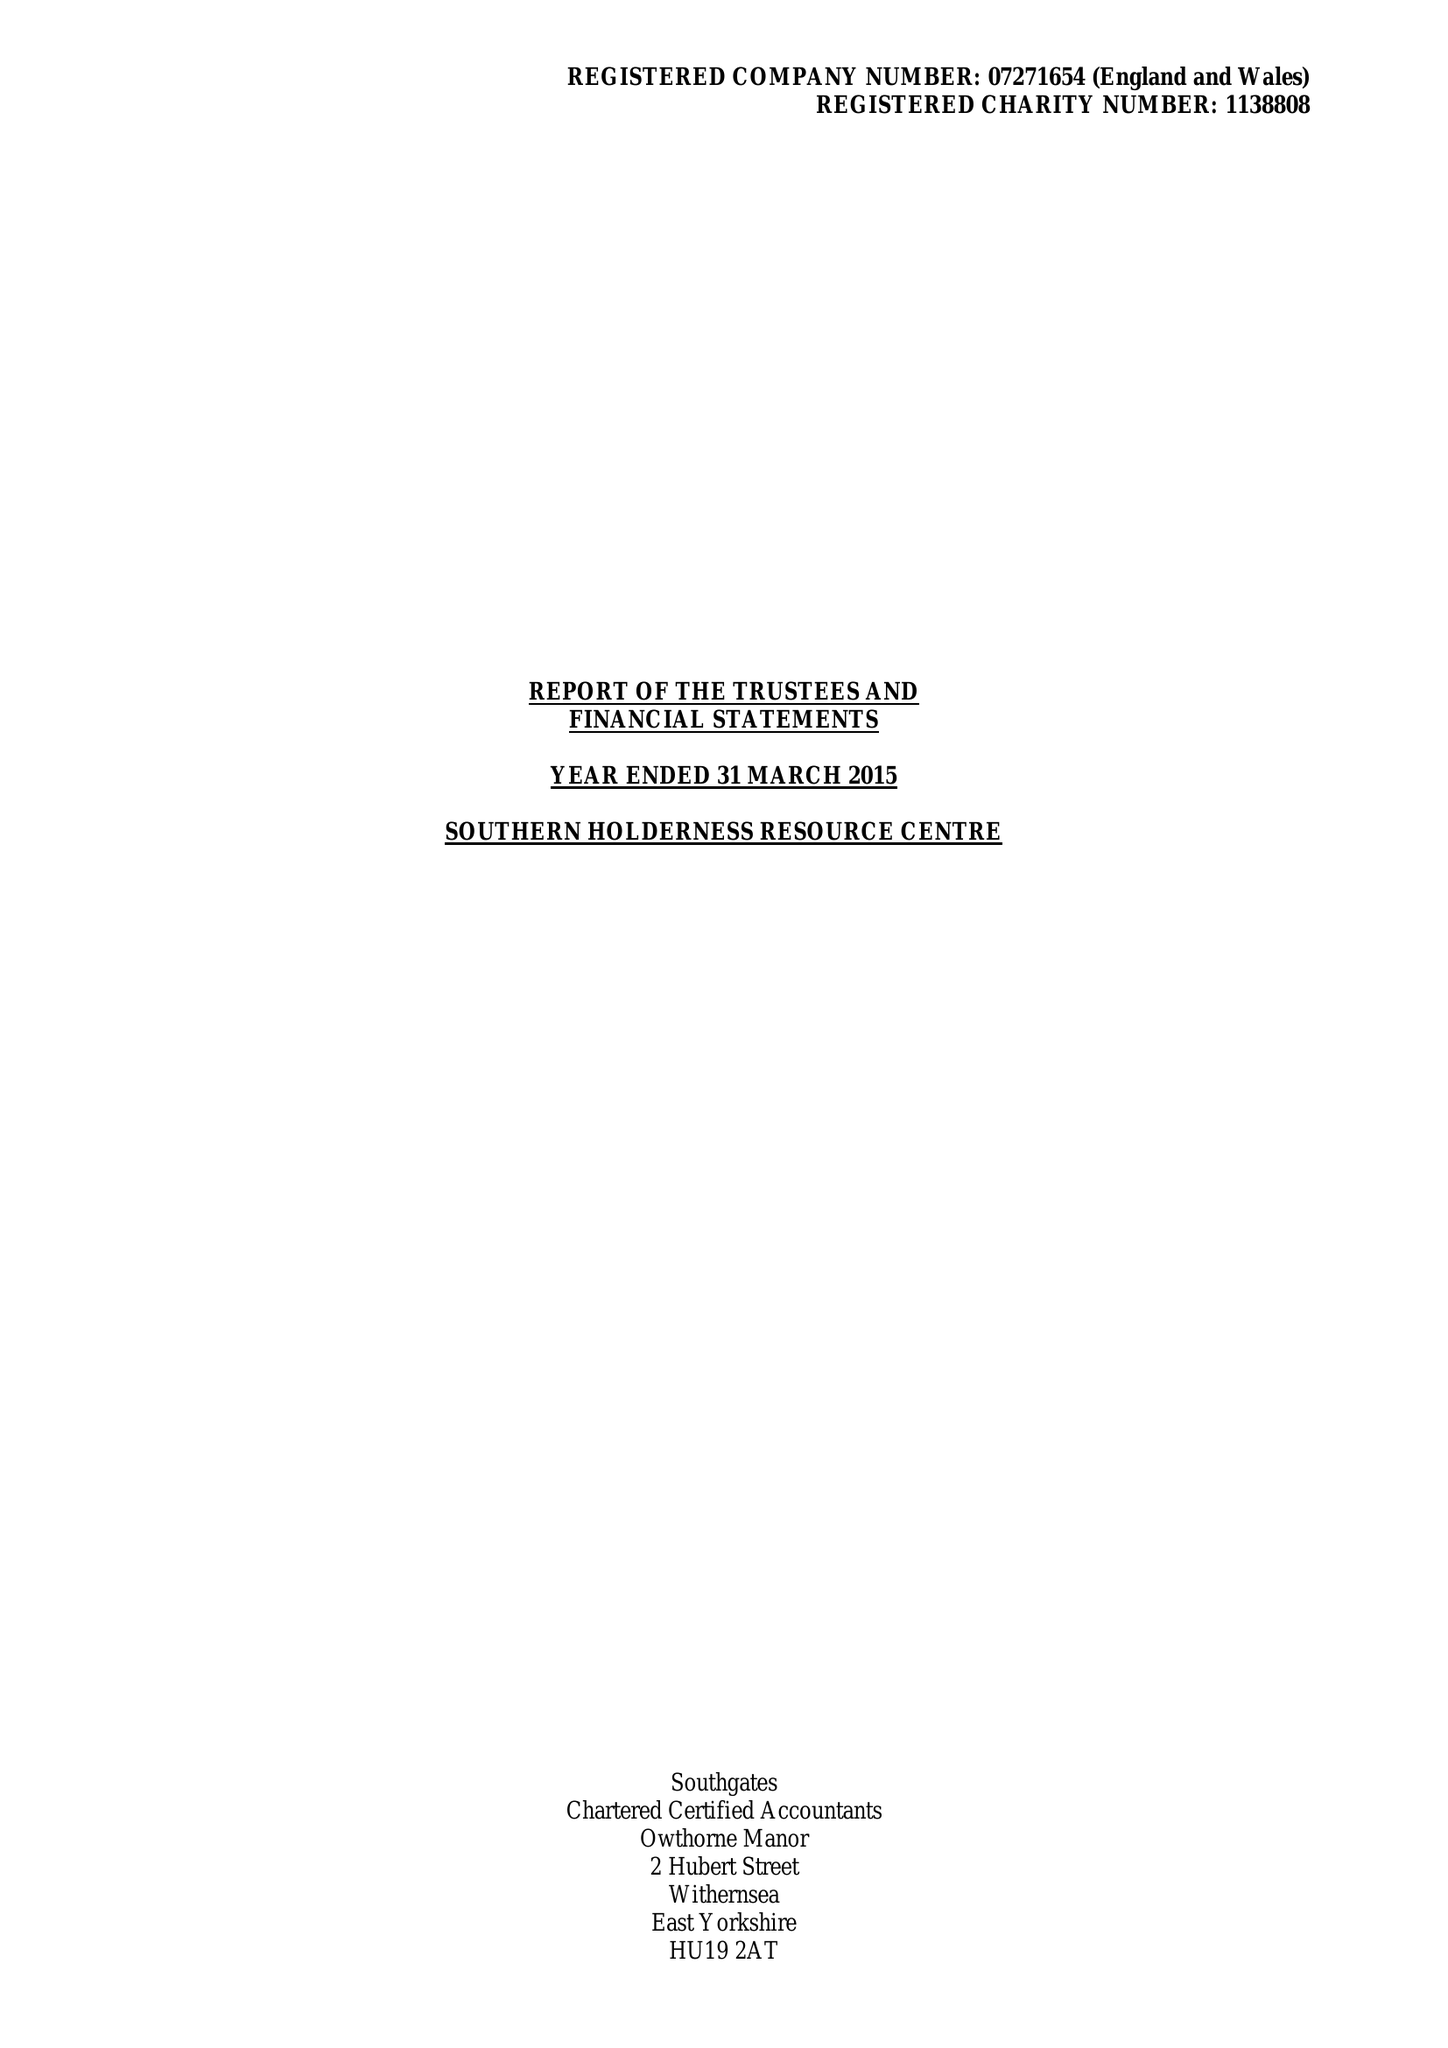What is the value for the charity_name?
Answer the question using a single word or phrase. Southern Holderness Resource Centre 